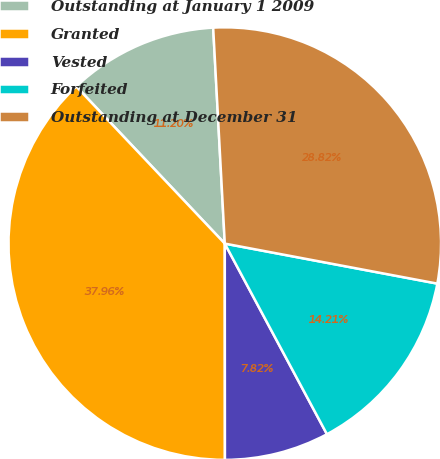<chart> <loc_0><loc_0><loc_500><loc_500><pie_chart><fcel>Outstanding at January 1 2009<fcel>Granted<fcel>Vested<fcel>Forfeited<fcel>Outstanding at December 31<nl><fcel>11.2%<fcel>37.96%<fcel>7.82%<fcel>14.21%<fcel>28.82%<nl></chart> 